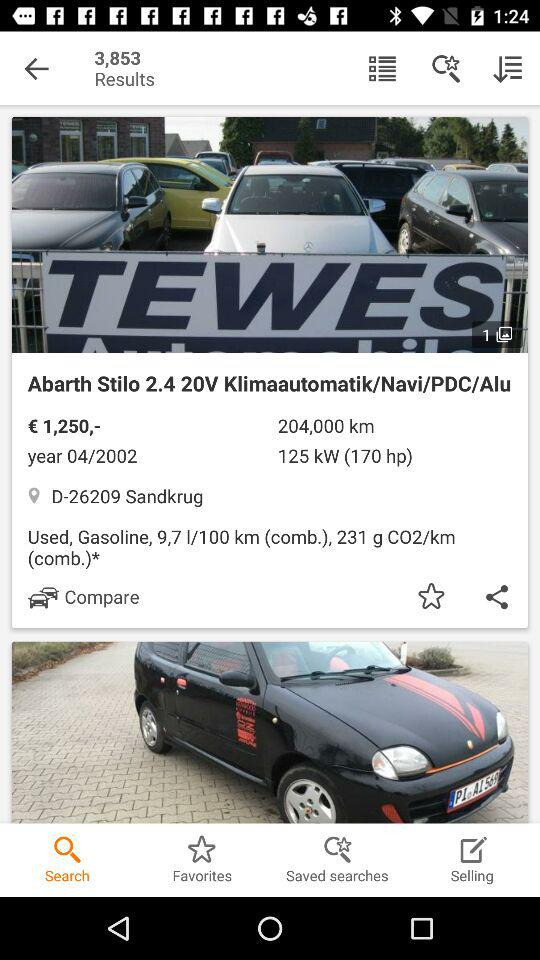How many kilometers are given there? The given number of kilometers is 204,000. 